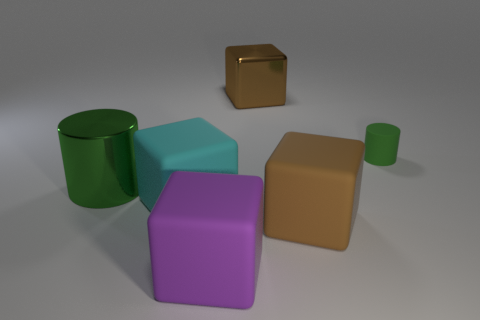There is a green cylinder that is on the left side of the green cylinder behind the large green shiny thing; is there a brown block on the left side of it?
Offer a very short reply. No. There is a green thing that is the same size as the brown rubber object; what is its shape?
Your answer should be very brief. Cylinder. How many other things are the same color as the small rubber cylinder?
Provide a succinct answer. 1. What is the small thing made of?
Provide a succinct answer. Rubber. How many other things are the same material as the big green object?
Provide a succinct answer. 1. There is a thing that is on the left side of the small rubber cylinder and behind the large green cylinder; what is its size?
Provide a short and direct response. Large. The green object right of the large brown object behind the small thing is what shape?
Your answer should be very brief. Cylinder. Is there any other thing that is the same shape as the small green rubber thing?
Offer a terse response. Yes. Are there an equal number of big purple rubber blocks to the right of the matte cylinder and large purple rubber cubes?
Offer a very short reply. No. There is a big shiny cylinder; does it have the same color as the matte object that is right of the brown rubber cube?
Make the answer very short. Yes. 